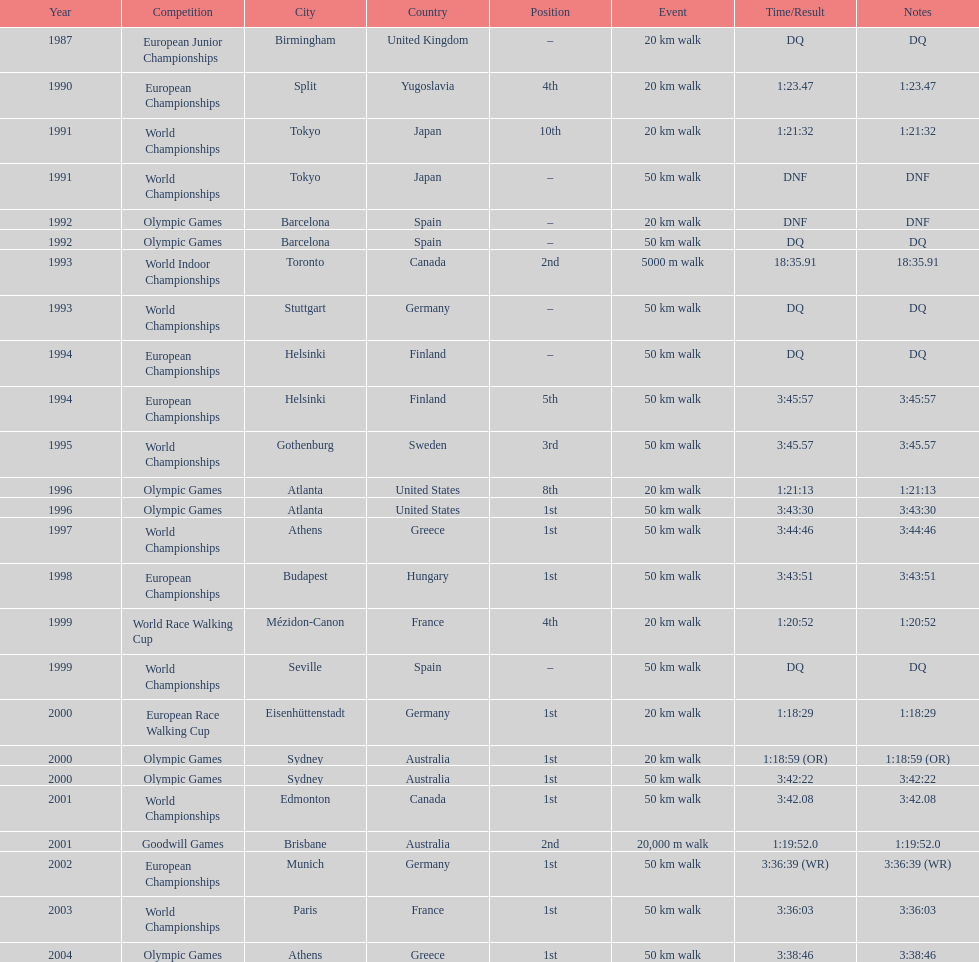Which venue is listed the most? Athens, Greece. 